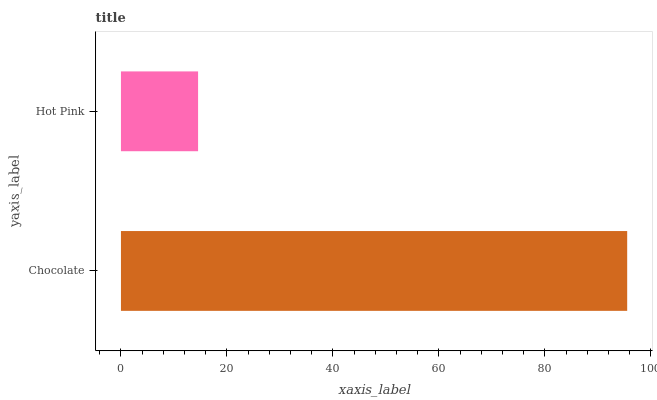Is Hot Pink the minimum?
Answer yes or no. Yes. Is Chocolate the maximum?
Answer yes or no. Yes. Is Hot Pink the maximum?
Answer yes or no. No. Is Chocolate greater than Hot Pink?
Answer yes or no. Yes. Is Hot Pink less than Chocolate?
Answer yes or no. Yes. Is Hot Pink greater than Chocolate?
Answer yes or no. No. Is Chocolate less than Hot Pink?
Answer yes or no. No. Is Chocolate the high median?
Answer yes or no. Yes. Is Hot Pink the low median?
Answer yes or no. Yes. Is Hot Pink the high median?
Answer yes or no. No. Is Chocolate the low median?
Answer yes or no. No. 